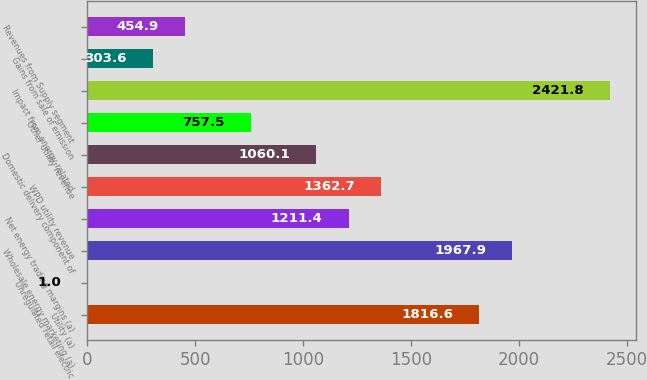Convert chart. <chart><loc_0><loc_0><loc_500><loc_500><bar_chart><fcel>Utility (a)<fcel>Unregulated retail electric<fcel>Wholesale energy marketing (a)<fcel>Net energy trading margins (a)<fcel>WPD utility revenue<fcel>Domestic delivery component of<fcel>Other utility revenue<fcel>Impact from energy-related<fcel>Gains from sale of emission<fcel>Revenues from Supply segment<nl><fcel>1816.6<fcel>1<fcel>1967.9<fcel>1211.4<fcel>1362.7<fcel>1060.1<fcel>757.5<fcel>2421.8<fcel>303.6<fcel>454.9<nl></chart> 